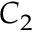<formula> <loc_0><loc_0><loc_500><loc_500>C _ { 2 }</formula> 